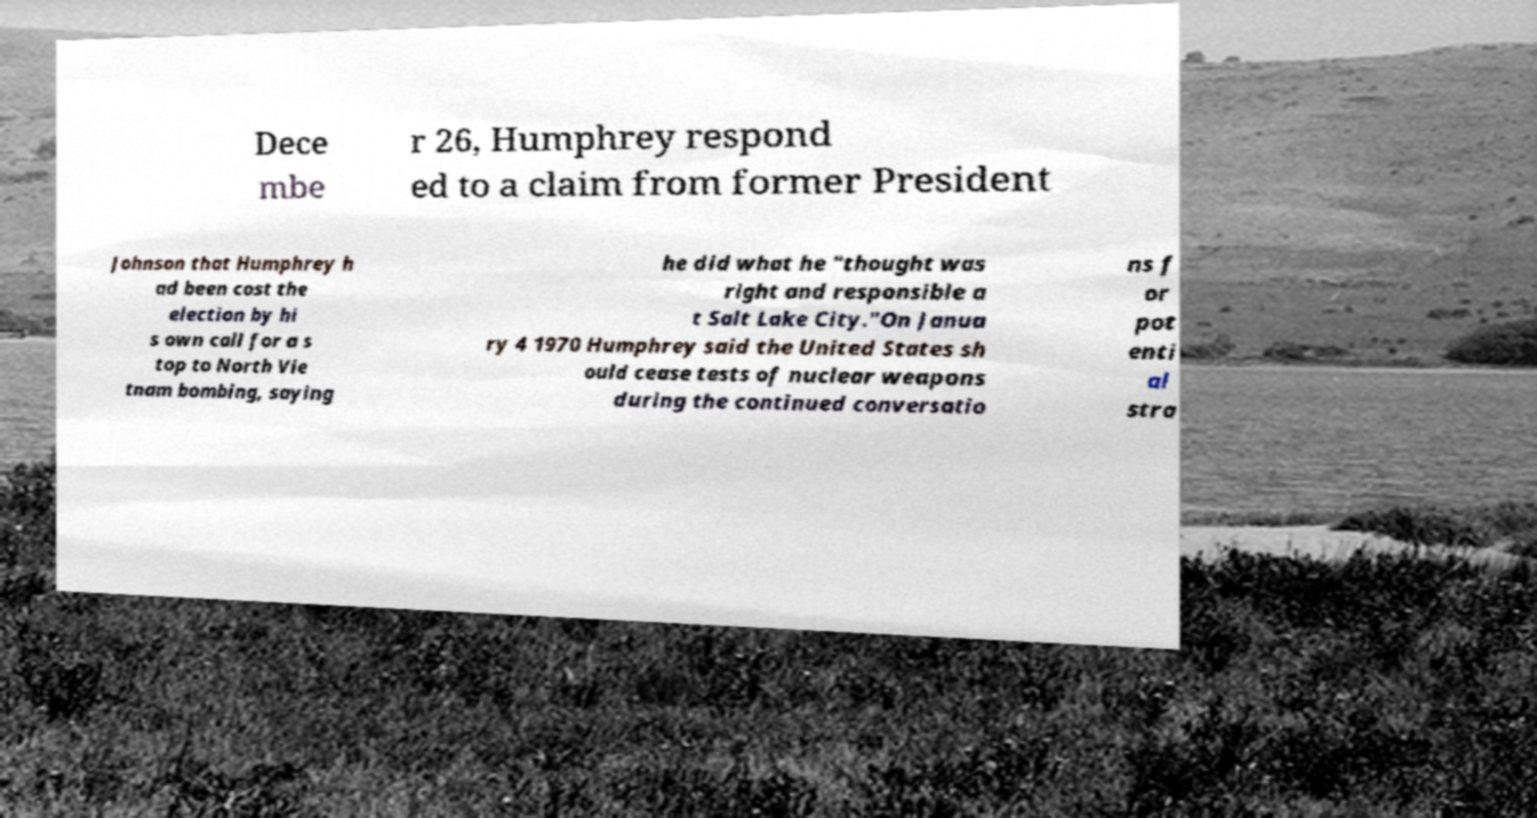Could you assist in decoding the text presented in this image and type it out clearly? Dece mbe r 26, Humphrey respond ed to a claim from former President Johnson that Humphrey h ad been cost the election by hi s own call for a s top to North Vie tnam bombing, saying he did what he "thought was right and responsible a t Salt Lake City."On Janua ry 4 1970 Humphrey said the United States sh ould cease tests of nuclear weapons during the continued conversatio ns f or pot enti al stra 